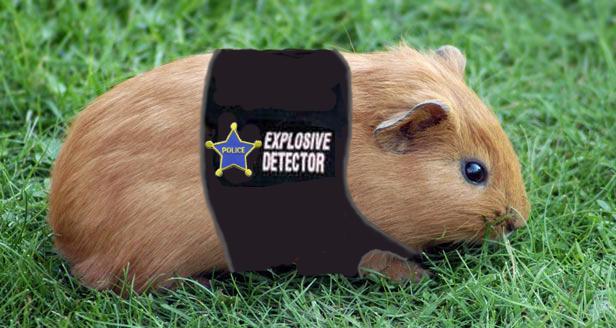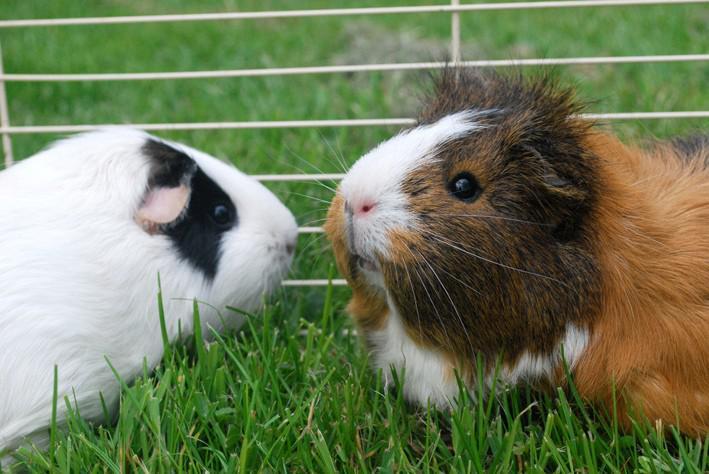The first image is the image on the left, the second image is the image on the right. For the images displayed, is the sentence "An image shows a pet rodent dressed in a uniform vest costume." factually correct? Answer yes or no. Yes. The first image is the image on the left, the second image is the image on the right. Assess this claim about the two images: "Three gerbils are in a grassy outdoor area, one alone wearing a costume, while two of different colors are together.". Correct or not? Answer yes or no. Yes. 